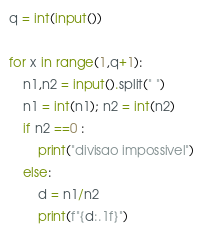Convert code to text. <code><loc_0><loc_0><loc_500><loc_500><_Python_>q = int(input())

for x in range(1,q+1):
    n1,n2 = input().split(" ")
    n1 = int(n1); n2 = int(n2)
    if n2 ==0 :
        print("divisao impossivel")
    else:
        d = n1/n2
        print(f"{d:.1f}")
</code> 